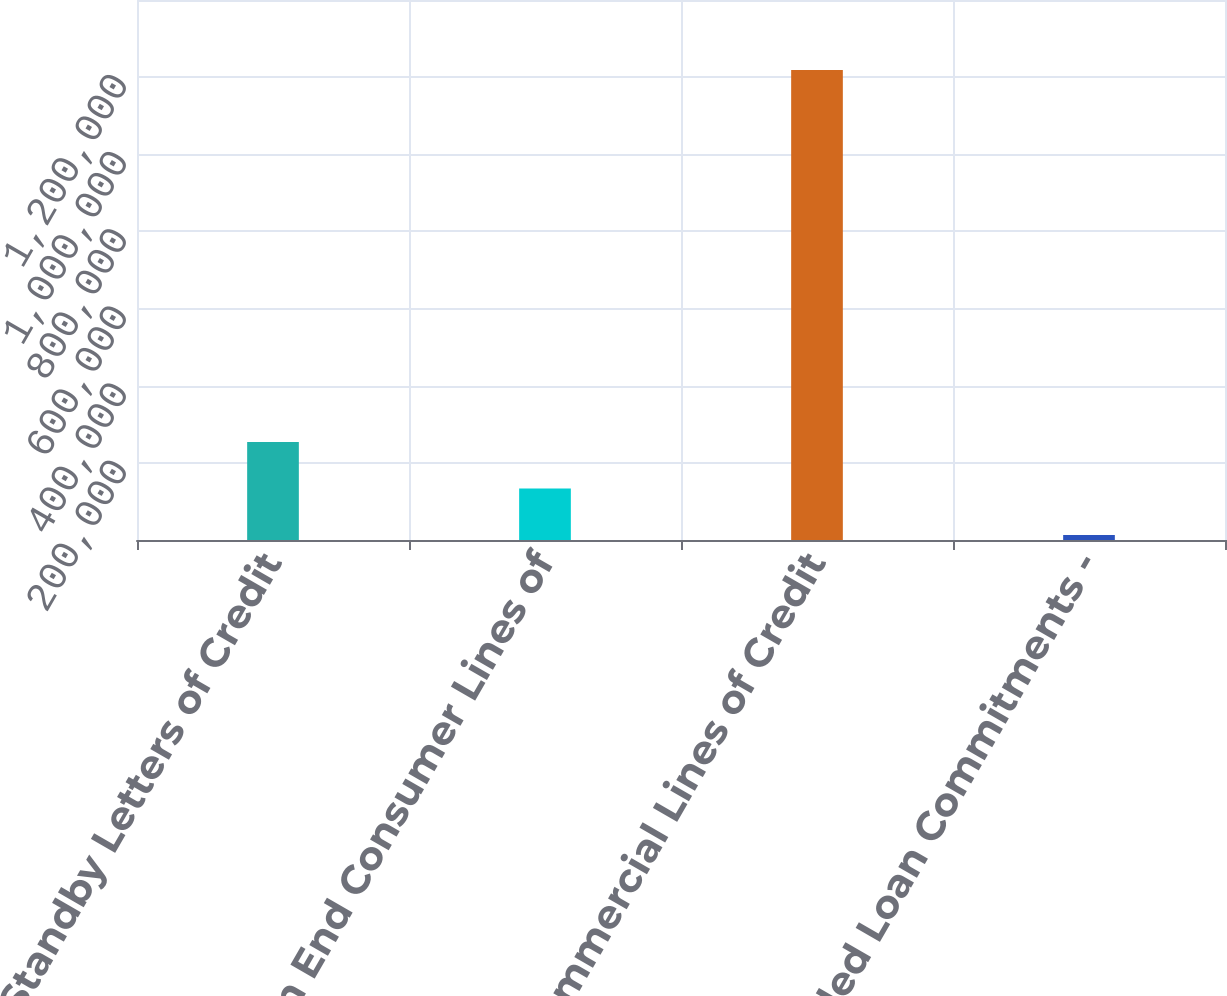Convert chart. <chart><loc_0><loc_0><loc_500><loc_500><bar_chart><fcel>Standby Letters of Credit<fcel>Open End Consumer Lines of<fcel>Commercial Lines of Credit<fcel>Unfunded Loan Commitments -<nl><fcel>254003<fcel>133417<fcel>1.21869e+06<fcel>12831<nl></chart> 